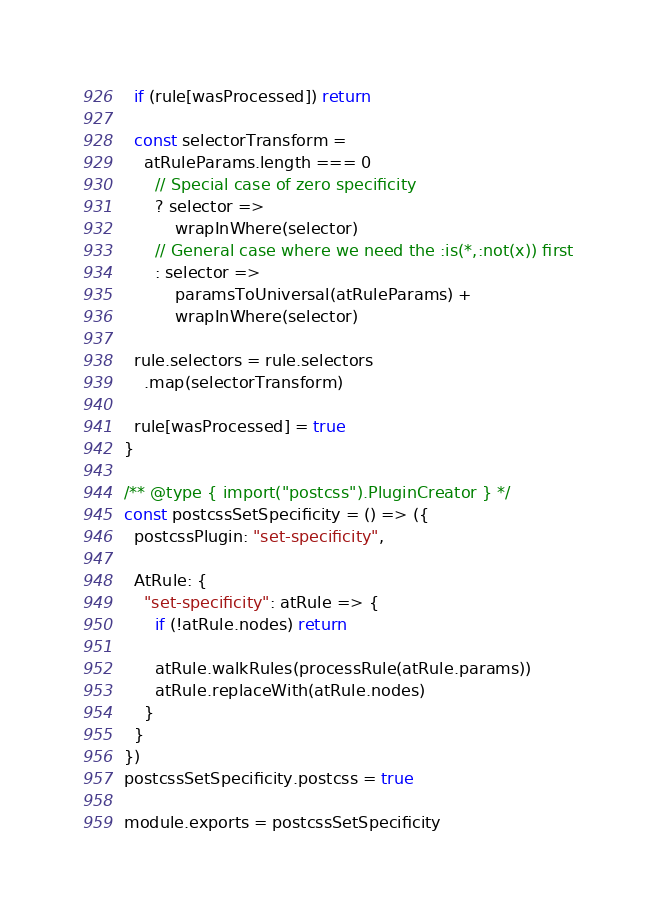Convert code to text. <code><loc_0><loc_0><loc_500><loc_500><_JavaScript_>  if (rule[wasProcessed]) return

  const selectorTransform =
    atRuleParams.length === 0
      // Special case of zero specificity
      ? selector =>
          wrapInWhere(selector)
      // General case where we need the :is(*,:not(x)) first
      : selector =>
          paramsToUniversal(atRuleParams) +
          wrapInWhere(selector)

  rule.selectors = rule.selectors
    .map(selectorTransform)

  rule[wasProcessed] = true
}

/** @type { import("postcss").PluginCreator } */
const postcssSetSpecificity = () => ({
  postcssPlugin: "set-specificity",

  AtRule: {
    "set-specificity": atRule => {
      if (!atRule.nodes) return

      atRule.walkRules(processRule(atRule.params))
      atRule.replaceWith(atRule.nodes)
    }
  }
})
postcssSetSpecificity.postcss = true

module.exports = postcssSetSpecificity
</code> 